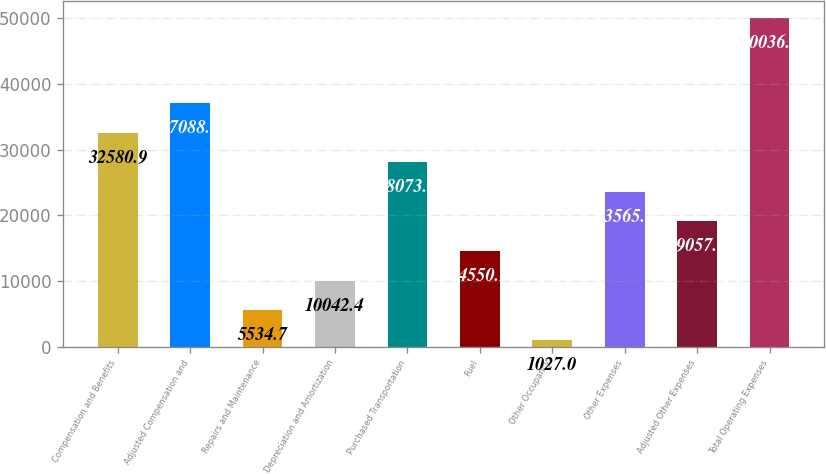Convert chart. <chart><loc_0><loc_0><loc_500><loc_500><bar_chart><fcel>Compensation and Benefits<fcel>Adjusted Compensation and<fcel>Repairs and Maintenance<fcel>Depreciation and Amortization<fcel>Purchased Transportation<fcel>Fuel<fcel>Other Occupancy<fcel>Other Expenses<fcel>Adjusted Other Expenses<fcel>Total Operating Expenses<nl><fcel>32580.9<fcel>37088.6<fcel>5534.7<fcel>10042.4<fcel>28073.2<fcel>14550.1<fcel>1027<fcel>23565.5<fcel>19057.8<fcel>50036.7<nl></chart> 